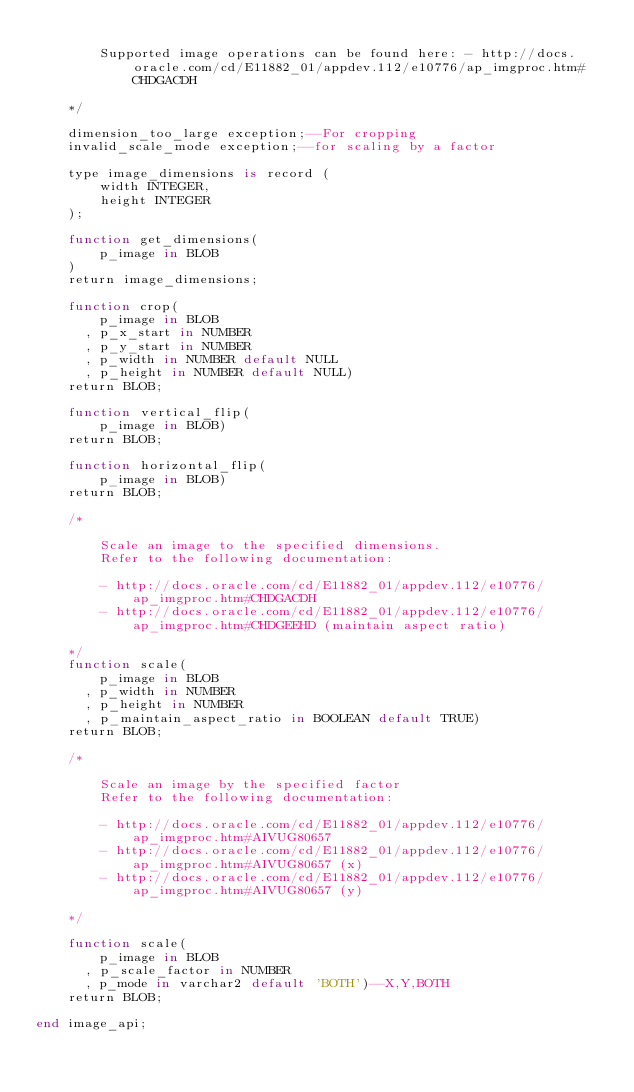Convert code to text. <code><loc_0><loc_0><loc_500><loc_500><_SQL_>
        Supported image operations can be found here: - http://docs.oracle.com/cd/E11882_01/appdev.112/e10776/ap_imgproc.htm#CHDGACDH 

    */

    dimension_too_large exception;--For cropping
    invalid_scale_mode exception;--for scaling by a factor

    type image_dimensions is record (
        width INTEGER,
        height INTEGER
    );

    function get_dimensions(
        p_image in BLOB
    )
    return image_dimensions;

    function crop(
        p_image in BLOB
      , p_x_start in NUMBER
      , p_y_start in NUMBER
      , p_width in NUMBER default NULL
      , p_height in NUMBER default NULL)
    return BLOB;

    function vertical_flip(
        p_image in BLOB)
    return BLOB;

    function horizontal_flip(
        p_image in BLOB)
    return BLOB;

    /*

        Scale an image to the specified dimensions.
        Refer to the following documentation:

        - http://docs.oracle.com/cd/E11882_01/appdev.112/e10776/ap_imgproc.htm#CHDGACDH
        - http://docs.oracle.com/cd/E11882_01/appdev.112/e10776/ap_imgproc.htm#CHDGEEHD (maintain aspect ratio)

    */
    function scale(
        p_image in BLOB
      , p_width in NUMBER
      , p_height in NUMBER
      , p_maintain_aspect_ratio in BOOLEAN default TRUE)
    return BLOB;
    
    /*
    
        Scale an image by the specified factor
        Refer to the following documentation:
        
        - http://docs.oracle.com/cd/E11882_01/appdev.112/e10776/ap_imgproc.htm#AIVUG80657
        - http://docs.oracle.com/cd/E11882_01/appdev.112/e10776/ap_imgproc.htm#AIVUG80657 (x)
        - http://docs.oracle.com/cd/E11882_01/appdev.112/e10776/ap_imgproc.htm#AIVUG80657 (y)
    
    */
    
    function scale(
        p_image in BLOB
      , p_scale_factor in NUMBER
      , p_mode in varchar2 default 'BOTH')--X,Y,BOTH
    return BLOB;  

end image_api;
</code> 